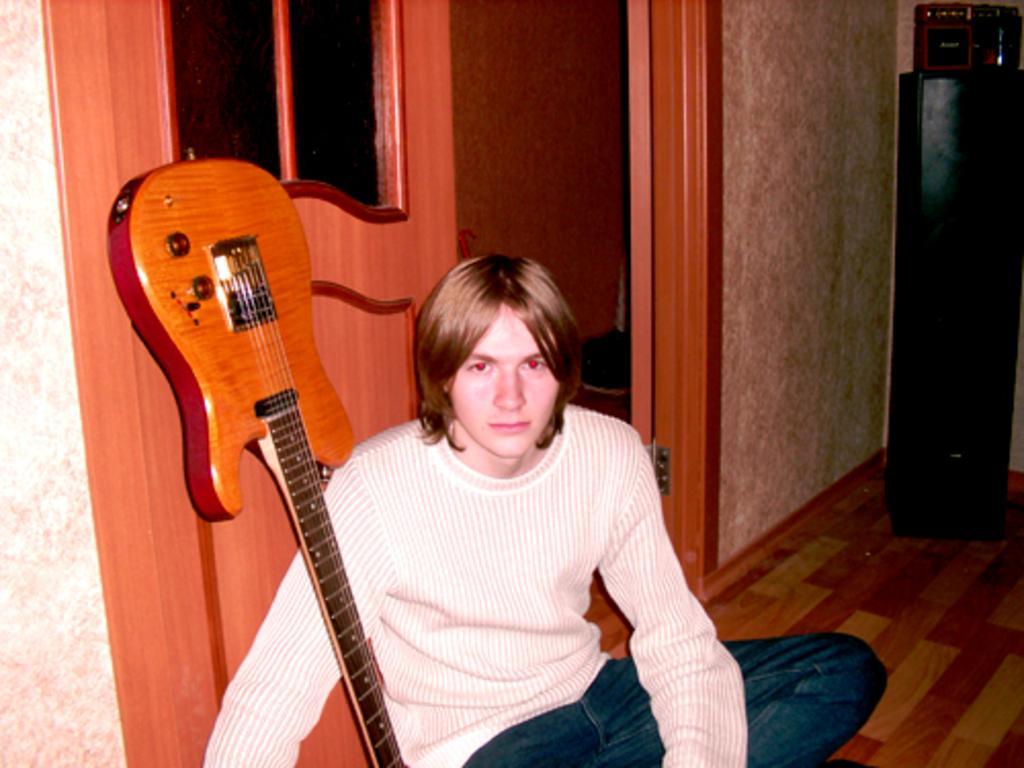Could you give a brief overview of what you see in this image? This picture is taken inside a room. There is a person sitting wearing a white shirt and jeans is having a guitar beside to him. He is sitting at the door. There is a stand at the right side of the image. 